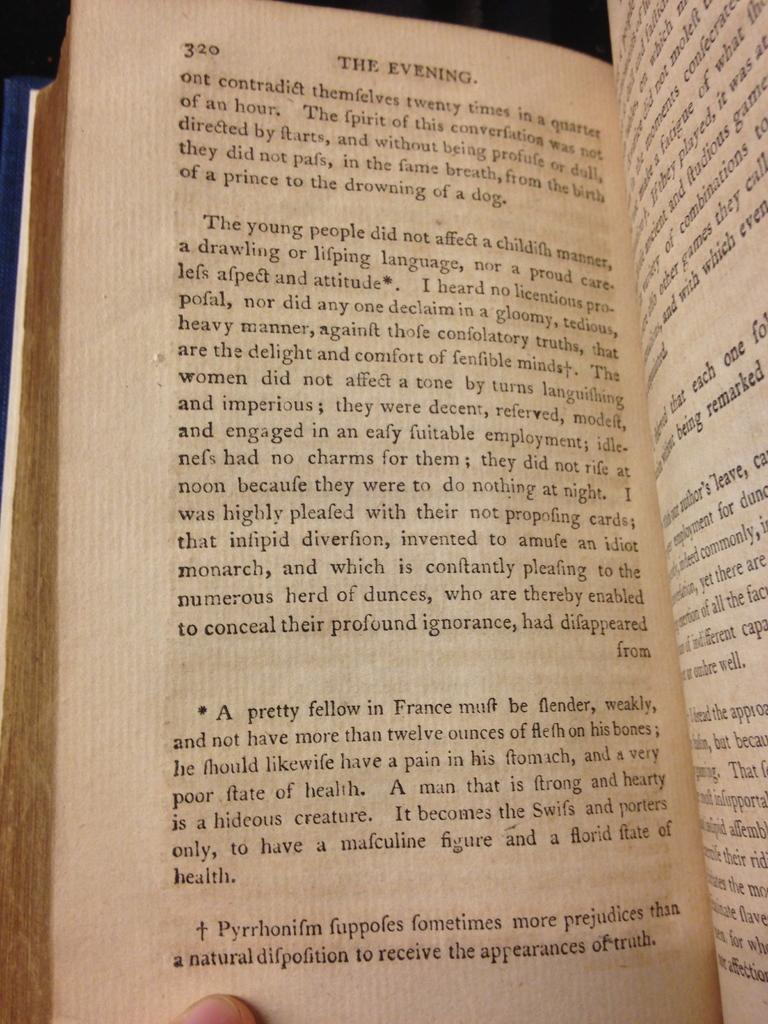<image>
Write a terse but informative summary of the picture. A book open to page 320 with the heading The Evening. 